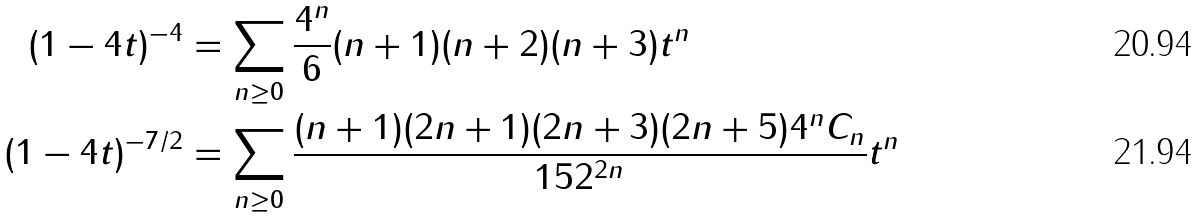<formula> <loc_0><loc_0><loc_500><loc_500>( 1 - 4 t ) ^ { - 4 } & = \sum _ { n \geq 0 } \frac { 4 ^ { n } } { 6 } ( n + 1 ) ( n + 2 ) ( n + 3 ) t ^ { n } \\ ( 1 - 4 t ) ^ { - 7 / 2 } & = \sum _ { n \geq 0 } \frac { ( n + 1 ) ( 2 n + 1 ) ( 2 n + 3 ) ( 2 n + 5 ) 4 ^ { n } C _ { n } } { 1 5 2 ^ { 2 n } } t ^ { n }</formula> 